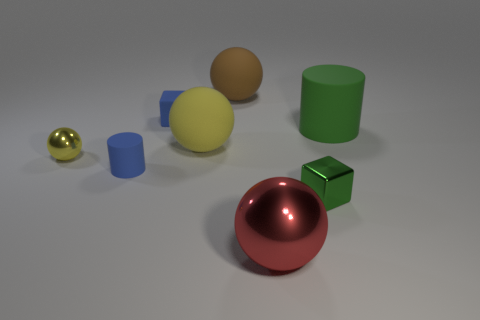What is the block that is right of the big red metal object made of? The block to the right of the large red sphere appears to have a metallic finish similar to the sphere, suggesting it is likely made of a metal or a metal-like material. 